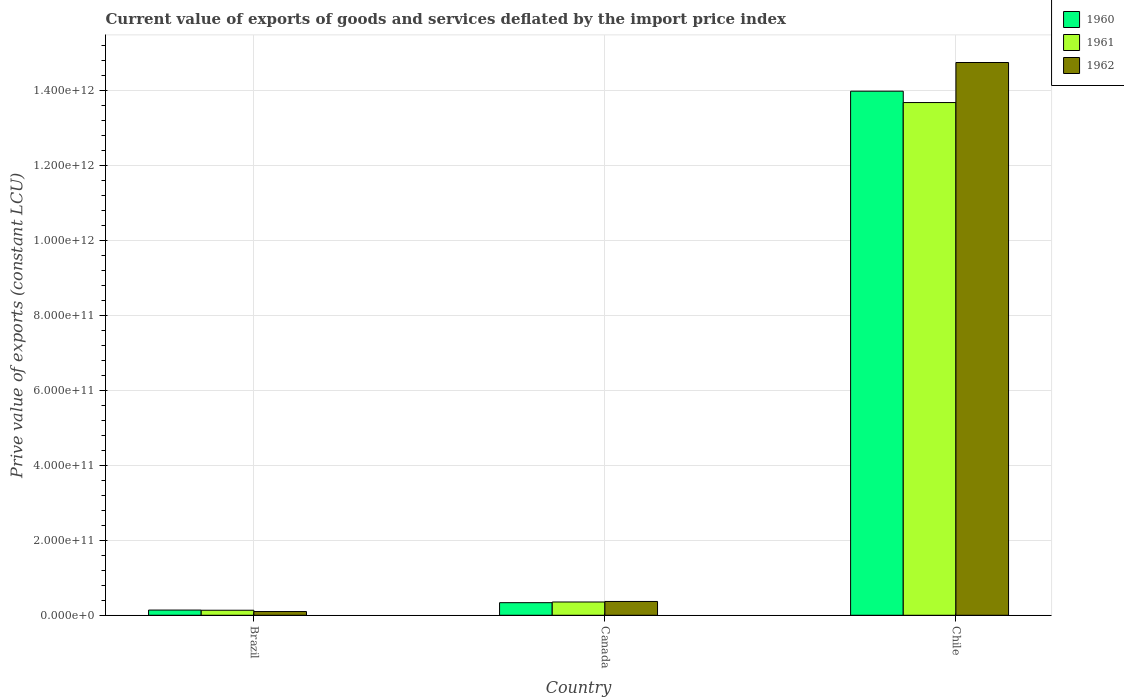How many different coloured bars are there?
Your answer should be compact. 3. How many groups of bars are there?
Your answer should be compact. 3. Are the number of bars on each tick of the X-axis equal?
Your response must be concise. Yes. How many bars are there on the 2nd tick from the left?
Offer a terse response. 3. What is the prive value of exports in 1960 in Brazil?
Give a very brief answer. 1.39e+1. Across all countries, what is the maximum prive value of exports in 1960?
Offer a very short reply. 1.40e+12. Across all countries, what is the minimum prive value of exports in 1961?
Give a very brief answer. 1.34e+1. What is the total prive value of exports in 1962 in the graph?
Keep it short and to the point. 1.52e+12. What is the difference between the prive value of exports in 1961 in Brazil and that in Chile?
Your answer should be compact. -1.36e+12. What is the difference between the prive value of exports in 1961 in Brazil and the prive value of exports in 1960 in Canada?
Keep it short and to the point. -2.02e+1. What is the average prive value of exports in 1960 per country?
Keep it short and to the point. 4.82e+11. What is the difference between the prive value of exports of/in 1962 and prive value of exports of/in 1960 in Brazil?
Provide a succinct answer. -3.94e+09. What is the ratio of the prive value of exports in 1962 in Brazil to that in Chile?
Offer a very short reply. 0.01. Is the prive value of exports in 1962 in Brazil less than that in Canada?
Make the answer very short. Yes. Is the difference between the prive value of exports in 1962 in Canada and Chile greater than the difference between the prive value of exports in 1960 in Canada and Chile?
Provide a short and direct response. No. What is the difference between the highest and the second highest prive value of exports in 1961?
Keep it short and to the point. -1.36e+12. What is the difference between the highest and the lowest prive value of exports in 1962?
Provide a succinct answer. 1.47e+12. In how many countries, is the prive value of exports in 1961 greater than the average prive value of exports in 1961 taken over all countries?
Ensure brevity in your answer.  1. Is the sum of the prive value of exports in 1961 in Brazil and Chile greater than the maximum prive value of exports in 1960 across all countries?
Provide a short and direct response. No. What does the 1st bar from the left in Chile represents?
Give a very brief answer. 1960. What does the 2nd bar from the right in Brazil represents?
Make the answer very short. 1961. Is it the case that in every country, the sum of the prive value of exports in 1962 and prive value of exports in 1961 is greater than the prive value of exports in 1960?
Ensure brevity in your answer.  Yes. What is the difference between two consecutive major ticks on the Y-axis?
Keep it short and to the point. 2.00e+11. Are the values on the major ticks of Y-axis written in scientific E-notation?
Give a very brief answer. Yes. Does the graph contain any zero values?
Keep it short and to the point. No. Where does the legend appear in the graph?
Offer a very short reply. Top right. How many legend labels are there?
Keep it short and to the point. 3. What is the title of the graph?
Make the answer very short. Current value of exports of goods and services deflated by the import price index. Does "1986" appear as one of the legend labels in the graph?
Make the answer very short. No. What is the label or title of the Y-axis?
Provide a short and direct response. Prive value of exports (constant LCU). What is the Prive value of exports (constant LCU) in 1960 in Brazil?
Ensure brevity in your answer.  1.39e+1. What is the Prive value of exports (constant LCU) of 1961 in Brazil?
Keep it short and to the point. 1.34e+1. What is the Prive value of exports (constant LCU) of 1962 in Brazil?
Provide a succinct answer. 9.97e+09. What is the Prive value of exports (constant LCU) in 1960 in Canada?
Ensure brevity in your answer.  3.37e+1. What is the Prive value of exports (constant LCU) in 1961 in Canada?
Ensure brevity in your answer.  3.55e+1. What is the Prive value of exports (constant LCU) of 1962 in Canada?
Provide a short and direct response. 3.69e+1. What is the Prive value of exports (constant LCU) of 1960 in Chile?
Your answer should be compact. 1.40e+12. What is the Prive value of exports (constant LCU) of 1961 in Chile?
Your answer should be compact. 1.37e+12. What is the Prive value of exports (constant LCU) in 1962 in Chile?
Your response must be concise. 1.48e+12. Across all countries, what is the maximum Prive value of exports (constant LCU) in 1960?
Your response must be concise. 1.40e+12. Across all countries, what is the maximum Prive value of exports (constant LCU) of 1961?
Give a very brief answer. 1.37e+12. Across all countries, what is the maximum Prive value of exports (constant LCU) of 1962?
Provide a succinct answer. 1.48e+12. Across all countries, what is the minimum Prive value of exports (constant LCU) in 1960?
Your response must be concise. 1.39e+1. Across all countries, what is the minimum Prive value of exports (constant LCU) in 1961?
Offer a terse response. 1.34e+1. Across all countries, what is the minimum Prive value of exports (constant LCU) of 1962?
Give a very brief answer. 9.97e+09. What is the total Prive value of exports (constant LCU) in 1960 in the graph?
Give a very brief answer. 1.45e+12. What is the total Prive value of exports (constant LCU) in 1961 in the graph?
Give a very brief answer. 1.42e+12. What is the total Prive value of exports (constant LCU) in 1962 in the graph?
Provide a short and direct response. 1.52e+12. What is the difference between the Prive value of exports (constant LCU) of 1960 in Brazil and that in Canada?
Your answer should be compact. -1.97e+1. What is the difference between the Prive value of exports (constant LCU) in 1961 in Brazil and that in Canada?
Make the answer very short. -2.20e+1. What is the difference between the Prive value of exports (constant LCU) in 1962 in Brazil and that in Canada?
Your answer should be very brief. -2.69e+1. What is the difference between the Prive value of exports (constant LCU) in 1960 in Brazil and that in Chile?
Provide a succinct answer. -1.39e+12. What is the difference between the Prive value of exports (constant LCU) of 1961 in Brazil and that in Chile?
Give a very brief answer. -1.36e+12. What is the difference between the Prive value of exports (constant LCU) of 1962 in Brazil and that in Chile?
Offer a very short reply. -1.47e+12. What is the difference between the Prive value of exports (constant LCU) of 1960 in Canada and that in Chile?
Keep it short and to the point. -1.37e+12. What is the difference between the Prive value of exports (constant LCU) in 1961 in Canada and that in Chile?
Give a very brief answer. -1.33e+12. What is the difference between the Prive value of exports (constant LCU) of 1962 in Canada and that in Chile?
Keep it short and to the point. -1.44e+12. What is the difference between the Prive value of exports (constant LCU) in 1960 in Brazil and the Prive value of exports (constant LCU) in 1961 in Canada?
Your answer should be very brief. -2.16e+1. What is the difference between the Prive value of exports (constant LCU) in 1960 in Brazil and the Prive value of exports (constant LCU) in 1962 in Canada?
Your response must be concise. -2.30e+1. What is the difference between the Prive value of exports (constant LCU) of 1961 in Brazil and the Prive value of exports (constant LCU) of 1962 in Canada?
Offer a very short reply. -2.34e+1. What is the difference between the Prive value of exports (constant LCU) in 1960 in Brazil and the Prive value of exports (constant LCU) in 1961 in Chile?
Your answer should be compact. -1.35e+12. What is the difference between the Prive value of exports (constant LCU) of 1960 in Brazil and the Prive value of exports (constant LCU) of 1962 in Chile?
Provide a short and direct response. -1.46e+12. What is the difference between the Prive value of exports (constant LCU) of 1961 in Brazil and the Prive value of exports (constant LCU) of 1962 in Chile?
Your answer should be compact. -1.46e+12. What is the difference between the Prive value of exports (constant LCU) of 1960 in Canada and the Prive value of exports (constant LCU) of 1961 in Chile?
Offer a terse response. -1.34e+12. What is the difference between the Prive value of exports (constant LCU) in 1960 in Canada and the Prive value of exports (constant LCU) in 1962 in Chile?
Your answer should be compact. -1.44e+12. What is the difference between the Prive value of exports (constant LCU) in 1961 in Canada and the Prive value of exports (constant LCU) in 1962 in Chile?
Your response must be concise. -1.44e+12. What is the average Prive value of exports (constant LCU) in 1960 per country?
Provide a short and direct response. 4.82e+11. What is the average Prive value of exports (constant LCU) in 1961 per country?
Offer a terse response. 4.73e+11. What is the average Prive value of exports (constant LCU) of 1962 per country?
Keep it short and to the point. 5.07e+11. What is the difference between the Prive value of exports (constant LCU) in 1960 and Prive value of exports (constant LCU) in 1961 in Brazil?
Provide a short and direct response. 4.85e+08. What is the difference between the Prive value of exports (constant LCU) in 1960 and Prive value of exports (constant LCU) in 1962 in Brazil?
Offer a terse response. 3.94e+09. What is the difference between the Prive value of exports (constant LCU) of 1961 and Prive value of exports (constant LCU) of 1962 in Brazil?
Your answer should be compact. 3.46e+09. What is the difference between the Prive value of exports (constant LCU) of 1960 and Prive value of exports (constant LCU) of 1961 in Canada?
Give a very brief answer. -1.81e+09. What is the difference between the Prive value of exports (constant LCU) in 1960 and Prive value of exports (constant LCU) in 1962 in Canada?
Your answer should be very brief. -3.23e+09. What is the difference between the Prive value of exports (constant LCU) of 1961 and Prive value of exports (constant LCU) of 1962 in Canada?
Offer a very short reply. -1.41e+09. What is the difference between the Prive value of exports (constant LCU) of 1960 and Prive value of exports (constant LCU) of 1961 in Chile?
Provide a succinct answer. 3.03e+1. What is the difference between the Prive value of exports (constant LCU) in 1960 and Prive value of exports (constant LCU) in 1962 in Chile?
Provide a succinct answer. -7.65e+1. What is the difference between the Prive value of exports (constant LCU) in 1961 and Prive value of exports (constant LCU) in 1962 in Chile?
Your answer should be compact. -1.07e+11. What is the ratio of the Prive value of exports (constant LCU) in 1960 in Brazil to that in Canada?
Your answer should be compact. 0.41. What is the ratio of the Prive value of exports (constant LCU) of 1961 in Brazil to that in Canada?
Give a very brief answer. 0.38. What is the ratio of the Prive value of exports (constant LCU) in 1962 in Brazil to that in Canada?
Provide a short and direct response. 0.27. What is the ratio of the Prive value of exports (constant LCU) of 1960 in Brazil to that in Chile?
Provide a short and direct response. 0.01. What is the ratio of the Prive value of exports (constant LCU) in 1961 in Brazil to that in Chile?
Keep it short and to the point. 0.01. What is the ratio of the Prive value of exports (constant LCU) of 1962 in Brazil to that in Chile?
Offer a terse response. 0.01. What is the ratio of the Prive value of exports (constant LCU) in 1960 in Canada to that in Chile?
Ensure brevity in your answer.  0.02. What is the ratio of the Prive value of exports (constant LCU) of 1961 in Canada to that in Chile?
Offer a terse response. 0.03. What is the ratio of the Prive value of exports (constant LCU) of 1962 in Canada to that in Chile?
Provide a succinct answer. 0.03. What is the difference between the highest and the second highest Prive value of exports (constant LCU) of 1960?
Provide a succinct answer. 1.37e+12. What is the difference between the highest and the second highest Prive value of exports (constant LCU) of 1961?
Your answer should be compact. 1.33e+12. What is the difference between the highest and the second highest Prive value of exports (constant LCU) in 1962?
Provide a succinct answer. 1.44e+12. What is the difference between the highest and the lowest Prive value of exports (constant LCU) of 1960?
Your response must be concise. 1.39e+12. What is the difference between the highest and the lowest Prive value of exports (constant LCU) of 1961?
Offer a terse response. 1.36e+12. What is the difference between the highest and the lowest Prive value of exports (constant LCU) in 1962?
Provide a short and direct response. 1.47e+12. 